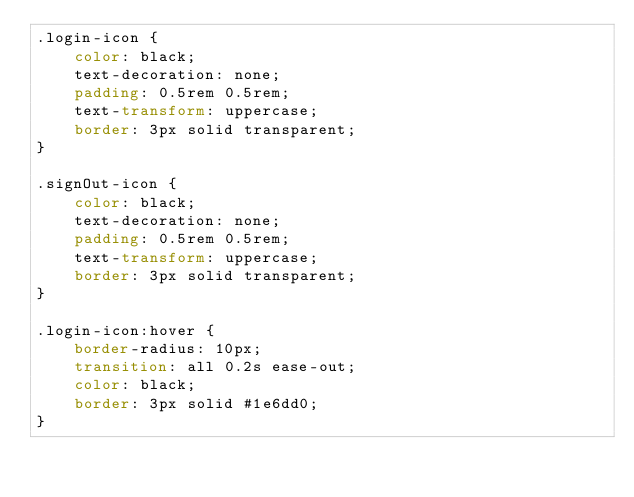<code> <loc_0><loc_0><loc_500><loc_500><_CSS_>.login-icon {
	color: black;
	text-decoration: none;
	padding: 0.5rem 0.5rem;
	text-transform: uppercase;
	border: 3px solid transparent;
}

.signOut-icon {
	color: black;
	text-decoration: none;
	padding: 0.5rem 0.5rem;
	text-transform: uppercase;
	border: 3px solid transparent;
}

.login-icon:hover {
	border-radius: 10px;
	transition: all 0.2s ease-out;
	color: black;
	border: 3px solid #1e6dd0;
}
</code> 